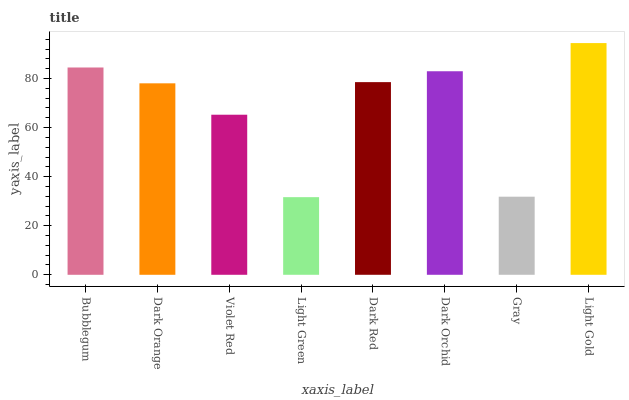Is Dark Orange the minimum?
Answer yes or no. No. Is Dark Orange the maximum?
Answer yes or no. No. Is Bubblegum greater than Dark Orange?
Answer yes or no. Yes. Is Dark Orange less than Bubblegum?
Answer yes or no. Yes. Is Dark Orange greater than Bubblegum?
Answer yes or no. No. Is Bubblegum less than Dark Orange?
Answer yes or no. No. Is Dark Red the high median?
Answer yes or no. Yes. Is Dark Orange the low median?
Answer yes or no. Yes. Is Bubblegum the high median?
Answer yes or no. No. Is Light Gold the low median?
Answer yes or no. No. 